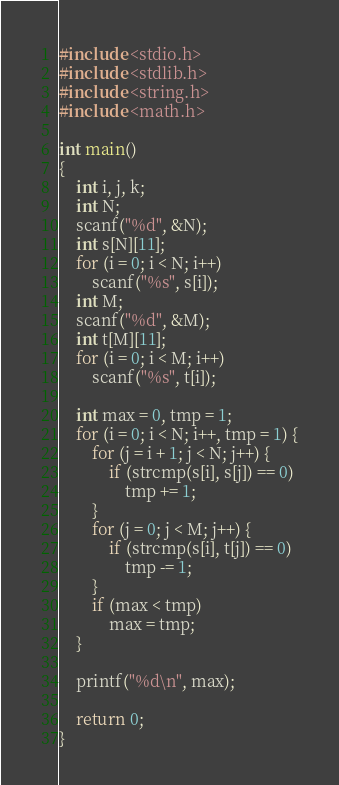<code> <loc_0><loc_0><loc_500><loc_500><_C_>#include <stdio.h>
#include <stdlib.h>
#include <string.h>
#include <math.h>

int main()
{
	int i, j, k;
	int N;
	scanf("%d", &N);
	int s[N][11];
	for (i = 0; i < N; i++)
		scanf("%s", s[i]);
	int M;
	scanf("%d", &M);
	int t[M][11];
	for (i = 0; i < M; i++)
		scanf("%s", t[i]);

	int max = 0, tmp = 1;
	for (i = 0; i < N; i++, tmp = 1) {
		for (j = i + 1; j < N; j++) {
			if (strcmp(s[i], s[j]) == 0)
				tmp += 1;
		}
		for (j = 0; j < M; j++) {
			if (strcmp(s[i], t[j]) == 0)
				tmp -= 1;
		}
		if (max < tmp)
			max = tmp;
	}

	printf("%d\n", max);

	return 0;
}
</code> 